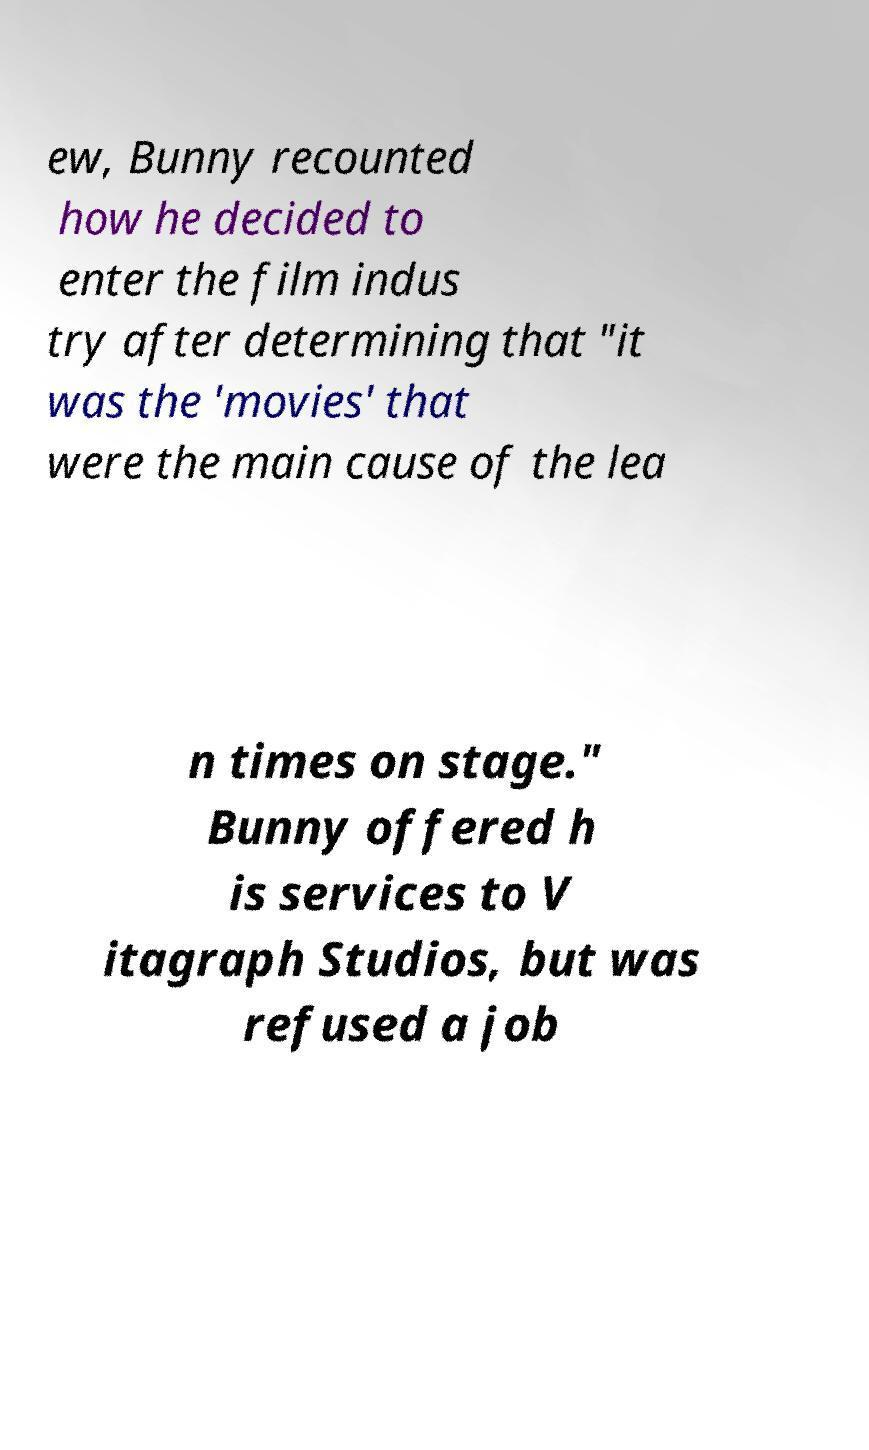There's text embedded in this image that I need extracted. Can you transcribe it verbatim? ew, Bunny recounted how he decided to enter the film indus try after determining that "it was the 'movies' that were the main cause of the lea n times on stage." Bunny offered h is services to V itagraph Studios, but was refused a job 